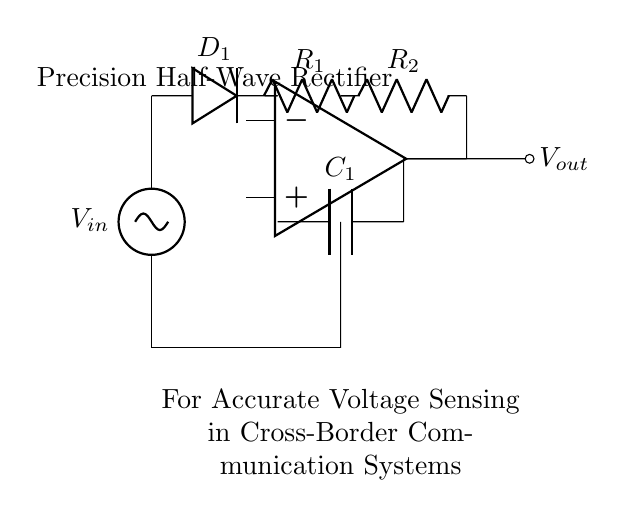What is the input voltage of the rectifier? The circuit shows an input voltage labeled as V_in, which is the source voltage.
Answer: V_in What type of diode is used in the circuit? The circuit diagram includes a component labeled D_1, indicating that it is a diode.
Answer: D_1 What are the values of R_1 and R_2? The circuit does not specify numeric values for R_1 and R_2. They are generic designators for resistors in the circuit.
Answer: R_1 and R_2 (values not specified) How many resistors are in the circuit? There are two resistors shown in the circuit diagram, labeled R_1 and R_2.
Answer: 2 What is the role of the capacitor C_1? In this rectifier circuit, capacitor C_1 is used for filtering, smoothing the output voltage to ensure accurate sensing.
Answer: Smoothing What happens when the input voltage is negative? The precision half-wave rectifier will only allow the positive half of the input waveform to pass through, blocking any negative voltage, making the output zero during negative cycles.
Answer: Output is zero What type of rectifier is represented in this circuit? The circuit is identified as a precision half-wave rectifier, meaning it only allows the positive half of the input signal to be transmitted while providing accuracy in the output voltage.
Answer: Precision half-wave 